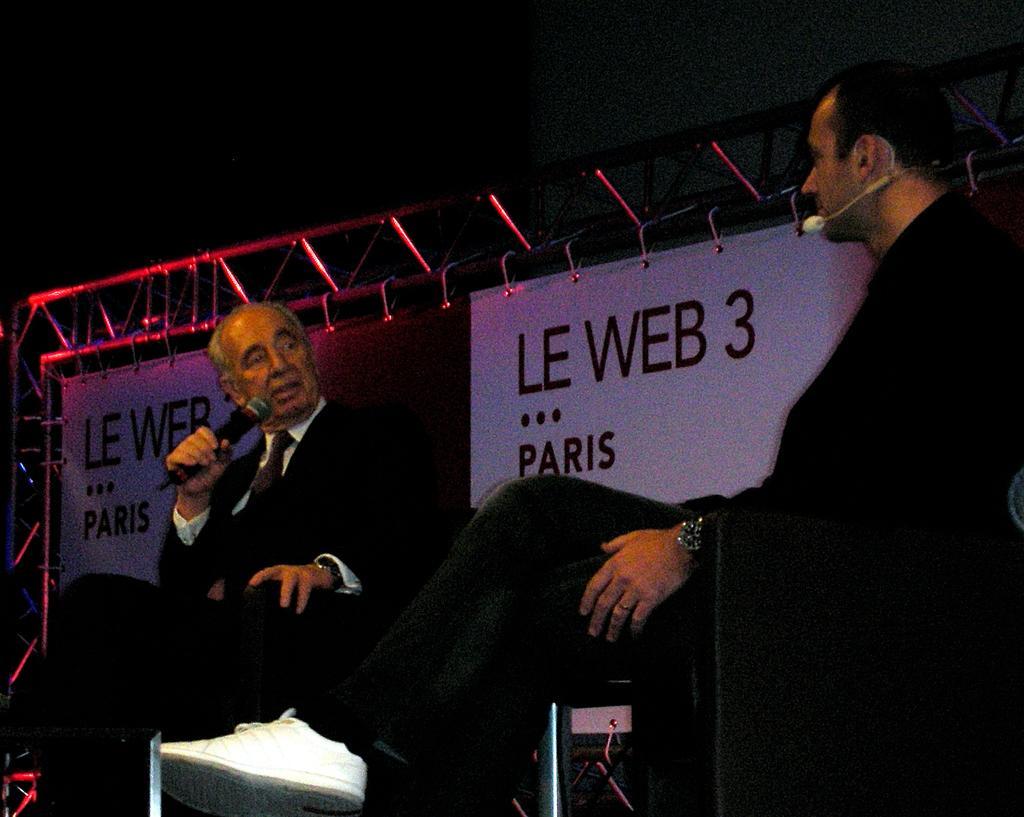Could you give a brief overview of what you see in this image? In this image we can see two persons sitting. Both are wearing watches. One person is holding mic. In the back there are banners with text. Also there is a stand. In the background it is dark. 